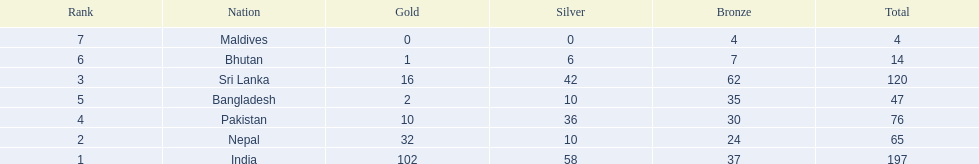What are the nations? India, Nepal, Sri Lanka, Pakistan, Bangladesh, Bhutan, Maldives. Of these, which one has earned the least amount of gold medals? Maldives. 